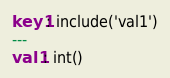Convert code to text. <code><loc_0><loc_0><loc_500><loc_500><_YAML_>key1: include('val1')
---
val1: int()</code> 